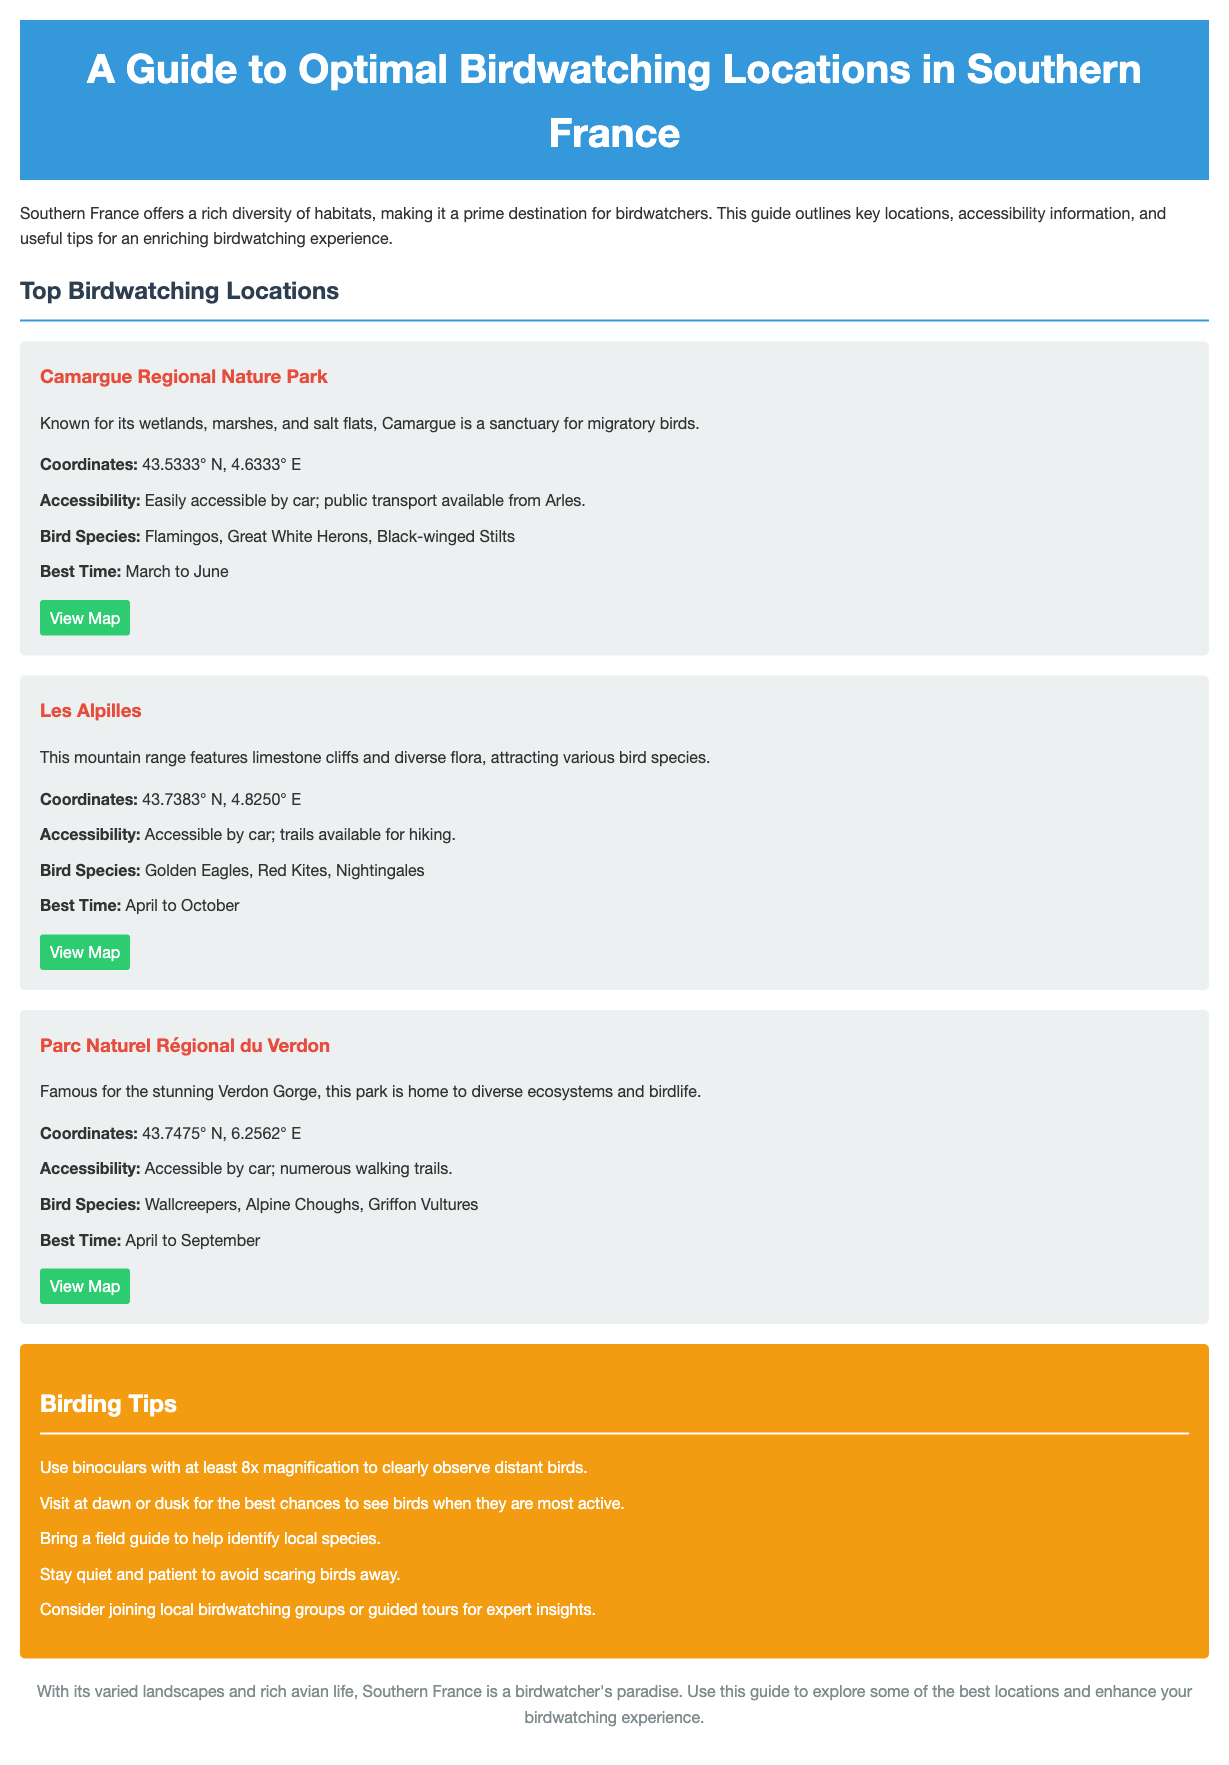What is the best time to visit Camargue? The best time to visit Camargue is mentioned in the section detailing this location, stating March to June.
Answer: March to June What bird species can be found in Les Alpilles? The document lists the bird species found in Les Alpilles, which include Golden Eagles, Red Kites, and Nightingales.
Answer: Golden Eagles, Red Kites, Nightingales How many locations are detailed in the guide? The guide outlines three key birdwatching locations in Southern France, as per the main sections presented.
Answer: Three What is the accessibility option for Parc Naturel Régional du Verdon? In the section for Parc Naturel Régional du Verdon, it states that the park is accessible by car; numerous walking trails are available.
Answer: Accessible by car; numerous walking trails What is a suggested time of day for optimal birdwatching? The birding tips section suggests visiting at dawn or dusk for the best chances to see birds when they are most active.
Answer: Dawn or dusk What type of guide should one bring to help identify birds? The document specifically recommends bringing a field guide to help identify local species while birdwatching.
Answer: Field guide Where can one find the map for Les Alpilles? The location information for Les Alpilles includes a link to view the map, directing readers to the Les Alpilles website to access it.
Answer: https://www.lesalpilles.com/map What color is used for the background in the document? The body background color is specified in the style section of the document as light gray (#f4f4f4).
Answer: Light gray 